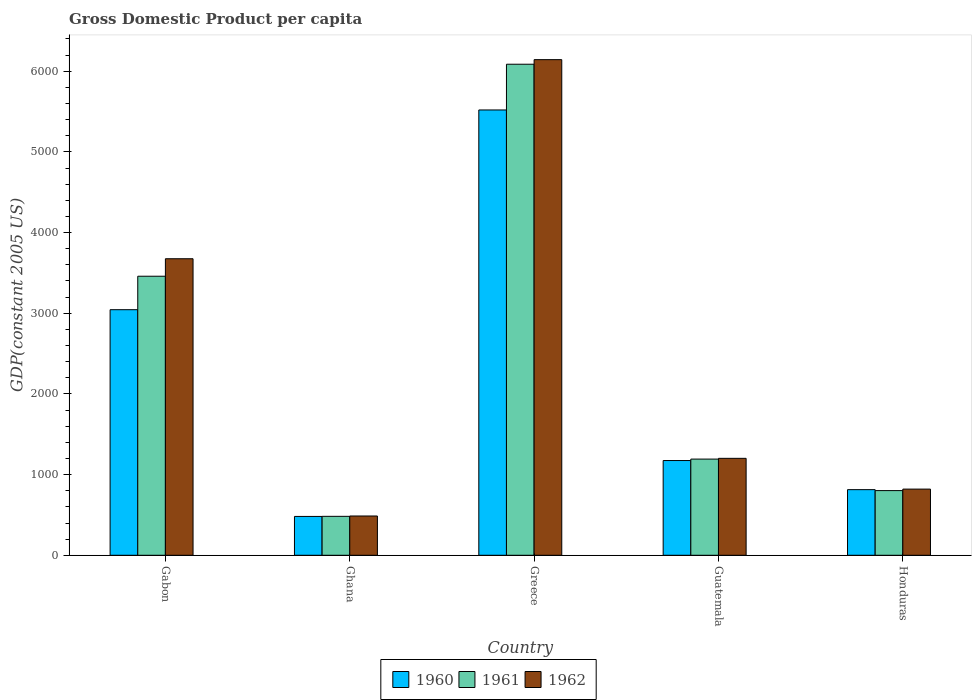How many groups of bars are there?
Give a very brief answer. 5. Are the number of bars per tick equal to the number of legend labels?
Your answer should be very brief. Yes. What is the GDP per capita in 1961 in Ghana?
Your response must be concise. 482.59. Across all countries, what is the maximum GDP per capita in 1961?
Offer a very short reply. 6087.1. Across all countries, what is the minimum GDP per capita in 1961?
Your response must be concise. 482.59. In which country was the GDP per capita in 1962 maximum?
Make the answer very short. Greece. In which country was the GDP per capita in 1960 minimum?
Your answer should be compact. Ghana. What is the total GDP per capita in 1961 in the graph?
Provide a short and direct response. 1.20e+04. What is the difference between the GDP per capita in 1960 in Greece and that in Guatemala?
Provide a succinct answer. 4345.65. What is the difference between the GDP per capita in 1960 in Greece and the GDP per capita in 1962 in Ghana?
Offer a terse response. 5033.19. What is the average GDP per capita in 1960 per country?
Offer a very short reply. 2206.74. What is the difference between the GDP per capita of/in 1960 and GDP per capita of/in 1962 in Gabon?
Provide a succinct answer. -631.6. In how many countries, is the GDP per capita in 1960 greater than 1600 US$?
Offer a terse response. 2. What is the ratio of the GDP per capita in 1962 in Ghana to that in Greece?
Offer a terse response. 0.08. What is the difference between the highest and the second highest GDP per capita in 1961?
Provide a succinct answer. -2266.73. What is the difference between the highest and the lowest GDP per capita in 1961?
Ensure brevity in your answer.  5604.5. What does the 2nd bar from the left in Honduras represents?
Offer a very short reply. 1961. How many bars are there?
Give a very brief answer. 15. Are all the bars in the graph horizontal?
Keep it short and to the point. No. How many countries are there in the graph?
Your answer should be very brief. 5. What is the difference between two consecutive major ticks on the Y-axis?
Ensure brevity in your answer.  1000. Does the graph contain grids?
Your response must be concise. No. How many legend labels are there?
Make the answer very short. 3. What is the title of the graph?
Make the answer very short. Gross Domestic Product per capita. What is the label or title of the X-axis?
Keep it short and to the point. Country. What is the label or title of the Y-axis?
Offer a very short reply. GDP(constant 2005 US). What is the GDP(constant 2005 US) of 1960 in Gabon?
Offer a very short reply. 3044.16. What is the GDP(constant 2005 US) in 1961 in Gabon?
Your response must be concise. 3459.15. What is the GDP(constant 2005 US) in 1962 in Gabon?
Your response must be concise. 3675.76. What is the GDP(constant 2005 US) of 1960 in Ghana?
Provide a succinct answer. 481.62. What is the GDP(constant 2005 US) of 1961 in Ghana?
Offer a terse response. 482.59. What is the GDP(constant 2005 US) of 1962 in Ghana?
Offer a very short reply. 486.9. What is the GDP(constant 2005 US) of 1960 in Greece?
Provide a succinct answer. 5520.09. What is the GDP(constant 2005 US) in 1961 in Greece?
Ensure brevity in your answer.  6087.1. What is the GDP(constant 2005 US) in 1962 in Greece?
Your answer should be very brief. 6143.73. What is the GDP(constant 2005 US) of 1960 in Guatemala?
Offer a terse response. 1174.44. What is the GDP(constant 2005 US) of 1961 in Guatemala?
Your answer should be very brief. 1192.42. What is the GDP(constant 2005 US) in 1962 in Guatemala?
Provide a succinct answer. 1201.57. What is the GDP(constant 2005 US) of 1960 in Honduras?
Provide a succinct answer. 813.41. What is the GDP(constant 2005 US) of 1961 in Honduras?
Ensure brevity in your answer.  801.77. What is the GDP(constant 2005 US) in 1962 in Honduras?
Make the answer very short. 820.2. Across all countries, what is the maximum GDP(constant 2005 US) of 1960?
Offer a very short reply. 5520.09. Across all countries, what is the maximum GDP(constant 2005 US) in 1961?
Provide a succinct answer. 6087.1. Across all countries, what is the maximum GDP(constant 2005 US) of 1962?
Your answer should be compact. 6143.73. Across all countries, what is the minimum GDP(constant 2005 US) of 1960?
Your answer should be very brief. 481.62. Across all countries, what is the minimum GDP(constant 2005 US) of 1961?
Provide a succinct answer. 482.59. Across all countries, what is the minimum GDP(constant 2005 US) of 1962?
Provide a succinct answer. 486.9. What is the total GDP(constant 2005 US) in 1960 in the graph?
Your answer should be compact. 1.10e+04. What is the total GDP(constant 2005 US) of 1961 in the graph?
Provide a short and direct response. 1.20e+04. What is the total GDP(constant 2005 US) of 1962 in the graph?
Your answer should be compact. 1.23e+04. What is the difference between the GDP(constant 2005 US) in 1960 in Gabon and that in Ghana?
Your answer should be very brief. 2562.54. What is the difference between the GDP(constant 2005 US) in 1961 in Gabon and that in Ghana?
Ensure brevity in your answer.  2976.55. What is the difference between the GDP(constant 2005 US) in 1962 in Gabon and that in Ghana?
Provide a succinct answer. 3188.86. What is the difference between the GDP(constant 2005 US) in 1960 in Gabon and that in Greece?
Provide a succinct answer. -2475.93. What is the difference between the GDP(constant 2005 US) of 1961 in Gabon and that in Greece?
Offer a very short reply. -2627.95. What is the difference between the GDP(constant 2005 US) in 1962 in Gabon and that in Greece?
Keep it short and to the point. -2467.97. What is the difference between the GDP(constant 2005 US) of 1960 in Gabon and that in Guatemala?
Provide a short and direct response. 1869.72. What is the difference between the GDP(constant 2005 US) in 1961 in Gabon and that in Guatemala?
Make the answer very short. 2266.73. What is the difference between the GDP(constant 2005 US) in 1962 in Gabon and that in Guatemala?
Keep it short and to the point. 2474.19. What is the difference between the GDP(constant 2005 US) of 1960 in Gabon and that in Honduras?
Make the answer very short. 2230.75. What is the difference between the GDP(constant 2005 US) of 1961 in Gabon and that in Honduras?
Provide a short and direct response. 2657.37. What is the difference between the GDP(constant 2005 US) of 1962 in Gabon and that in Honduras?
Offer a terse response. 2855.56. What is the difference between the GDP(constant 2005 US) of 1960 in Ghana and that in Greece?
Provide a short and direct response. -5038.47. What is the difference between the GDP(constant 2005 US) of 1961 in Ghana and that in Greece?
Ensure brevity in your answer.  -5604.5. What is the difference between the GDP(constant 2005 US) of 1962 in Ghana and that in Greece?
Your answer should be very brief. -5656.83. What is the difference between the GDP(constant 2005 US) in 1960 in Ghana and that in Guatemala?
Make the answer very short. -692.82. What is the difference between the GDP(constant 2005 US) in 1961 in Ghana and that in Guatemala?
Offer a terse response. -709.82. What is the difference between the GDP(constant 2005 US) of 1962 in Ghana and that in Guatemala?
Your response must be concise. -714.67. What is the difference between the GDP(constant 2005 US) in 1960 in Ghana and that in Honduras?
Give a very brief answer. -331.79. What is the difference between the GDP(constant 2005 US) in 1961 in Ghana and that in Honduras?
Ensure brevity in your answer.  -319.18. What is the difference between the GDP(constant 2005 US) in 1962 in Ghana and that in Honduras?
Your answer should be compact. -333.3. What is the difference between the GDP(constant 2005 US) of 1960 in Greece and that in Guatemala?
Make the answer very short. 4345.65. What is the difference between the GDP(constant 2005 US) of 1961 in Greece and that in Guatemala?
Make the answer very short. 4894.68. What is the difference between the GDP(constant 2005 US) of 1962 in Greece and that in Guatemala?
Offer a terse response. 4942.16. What is the difference between the GDP(constant 2005 US) in 1960 in Greece and that in Honduras?
Keep it short and to the point. 4706.68. What is the difference between the GDP(constant 2005 US) in 1961 in Greece and that in Honduras?
Your answer should be compact. 5285.32. What is the difference between the GDP(constant 2005 US) of 1962 in Greece and that in Honduras?
Give a very brief answer. 5323.53. What is the difference between the GDP(constant 2005 US) in 1960 in Guatemala and that in Honduras?
Offer a very short reply. 361.03. What is the difference between the GDP(constant 2005 US) of 1961 in Guatemala and that in Honduras?
Provide a succinct answer. 390.64. What is the difference between the GDP(constant 2005 US) of 1962 in Guatemala and that in Honduras?
Make the answer very short. 381.38. What is the difference between the GDP(constant 2005 US) of 1960 in Gabon and the GDP(constant 2005 US) of 1961 in Ghana?
Ensure brevity in your answer.  2561.57. What is the difference between the GDP(constant 2005 US) in 1960 in Gabon and the GDP(constant 2005 US) in 1962 in Ghana?
Provide a succinct answer. 2557.26. What is the difference between the GDP(constant 2005 US) in 1961 in Gabon and the GDP(constant 2005 US) in 1962 in Ghana?
Offer a very short reply. 2972.24. What is the difference between the GDP(constant 2005 US) in 1960 in Gabon and the GDP(constant 2005 US) in 1961 in Greece?
Your answer should be very brief. -3042.93. What is the difference between the GDP(constant 2005 US) of 1960 in Gabon and the GDP(constant 2005 US) of 1962 in Greece?
Provide a succinct answer. -3099.57. What is the difference between the GDP(constant 2005 US) of 1961 in Gabon and the GDP(constant 2005 US) of 1962 in Greece?
Provide a succinct answer. -2684.59. What is the difference between the GDP(constant 2005 US) in 1960 in Gabon and the GDP(constant 2005 US) in 1961 in Guatemala?
Make the answer very short. 1851.75. What is the difference between the GDP(constant 2005 US) in 1960 in Gabon and the GDP(constant 2005 US) in 1962 in Guatemala?
Offer a terse response. 1842.59. What is the difference between the GDP(constant 2005 US) in 1961 in Gabon and the GDP(constant 2005 US) in 1962 in Guatemala?
Offer a very short reply. 2257.57. What is the difference between the GDP(constant 2005 US) of 1960 in Gabon and the GDP(constant 2005 US) of 1961 in Honduras?
Offer a very short reply. 2242.39. What is the difference between the GDP(constant 2005 US) of 1960 in Gabon and the GDP(constant 2005 US) of 1962 in Honduras?
Offer a terse response. 2223.96. What is the difference between the GDP(constant 2005 US) of 1961 in Gabon and the GDP(constant 2005 US) of 1962 in Honduras?
Provide a short and direct response. 2638.95. What is the difference between the GDP(constant 2005 US) in 1960 in Ghana and the GDP(constant 2005 US) in 1961 in Greece?
Keep it short and to the point. -5605.48. What is the difference between the GDP(constant 2005 US) of 1960 in Ghana and the GDP(constant 2005 US) of 1962 in Greece?
Provide a short and direct response. -5662.11. What is the difference between the GDP(constant 2005 US) in 1961 in Ghana and the GDP(constant 2005 US) in 1962 in Greece?
Make the answer very short. -5661.14. What is the difference between the GDP(constant 2005 US) in 1960 in Ghana and the GDP(constant 2005 US) in 1961 in Guatemala?
Ensure brevity in your answer.  -710.8. What is the difference between the GDP(constant 2005 US) of 1960 in Ghana and the GDP(constant 2005 US) of 1962 in Guatemala?
Your response must be concise. -719.96. What is the difference between the GDP(constant 2005 US) of 1961 in Ghana and the GDP(constant 2005 US) of 1962 in Guatemala?
Ensure brevity in your answer.  -718.98. What is the difference between the GDP(constant 2005 US) of 1960 in Ghana and the GDP(constant 2005 US) of 1961 in Honduras?
Your answer should be compact. -320.16. What is the difference between the GDP(constant 2005 US) of 1960 in Ghana and the GDP(constant 2005 US) of 1962 in Honduras?
Your answer should be very brief. -338.58. What is the difference between the GDP(constant 2005 US) in 1961 in Ghana and the GDP(constant 2005 US) in 1962 in Honduras?
Give a very brief answer. -337.61. What is the difference between the GDP(constant 2005 US) in 1960 in Greece and the GDP(constant 2005 US) in 1961 in Guatemala?
Provide a succinct answer. 4327.67. What is the difference between the GDP(constant 2005 US) in 1960 in Greece and the GDP(constant 2005 US) in 1962 in Guatemala?
Provide a short and direct response. 4318.51. What is the difference between the GDP(constant 2005 US) of 1961 in Greece and the GDP(constant 2005 US) of 1962 in Guatemala?
Give a very brief answer. 4885.52. What is the difference between the GDP(constant 2005 US) in 1960 in Greece and the GDP(constant 2005 US) in 1961 in Honduras?
Make the answer very short. 4718.31. What is the difference between the GDP(constant 2005 US) in 1960 in Greece and the GDP(constant 2005 US) in 1962 in Honduras?
Your answer should be very brief. 4699.89. What is the difference between the GDP(constant 2005 US) of 1961 in Greece and the GDP(constant 2005 US) of 1962 in Honduras?
Give a very brief answer. 5266.9. What is the difference between the GDP(constant 2005 US) in 1960 in Guatemala and the GDP(constant 2005 US) in 1961 in Honduras?
Ensure brevity in your answer.  372.67. What is the difference between the GDP(constant 2005 US) in 1960 in Guatemala and the GDP(constant 2005 US) in 1962 in Honduras?
Your answer should be compact. 354.24. What is the difference between the GDP(constant 2005 US) of 1961 in Guatemala and the GDP(constant 2005 US) of 1962 in Honduras?
Keep it short and to the point. 372.22. What is the average GDP(constant 2005 US) of 1960 per country?
Keep it short and to the point. 2206.74. What is the average GDP(constant 2005 US) of 1961 per country?
Your response must be concise. 2404.61. What is the average GDP(constant 2005 US) of 1962 per country?
Provide a short and direct response. 2465.63. What is the difference between the GDP(constant 2005 US) of 1960 and GDP(constant 2005 US) of 1961 in Gabon?
Your response must be concise. -414.98. What is the difference between the GDP(constant 2005 US) of 1960 and GDP(constant 2005 US) of 1962 in Gabon?
Ensure brevity in your answer.  -631.6. What is the difference between the GDP(constant 2005 US) in 1961 and GDP(constant 2005 US) in 1962 in Gabon?
Your answer should be very brief. -216.62. What is the difference between the GDP(constant 2005 US) in 1960 and GDP(constant 2005 US) in 1961 in Ghana?
Give a very brief answer. -0.97. What is the difference between the GDP(constant 2005 US) in 1960 and GDP(constant 2005 US) in 1962 in Ghana?
Your answer should be compact. -5.28. What is the difference between the GDP(constant 2005 US) of 1961 and GDP(constant 2005 US) of 1962 in Ghana?
Your answer should be very brief. -4.31. What is the difference between the GDP(constant 2005 US) of 1960 and GDP(constant 2005 US) of 1961 in Greece?
Give a very brief answer. -567.01. What is the difference between the GDP(constant 2005 US) of 1960 and GDP(constant 2005 US) of 1962 in Greece?
Your answer should be very brief. -623.64. What is the difference between the GDP(constant 2005 US) of 1961 and GDP(constant 2005 US) of 1962 in Greece?
Provide a short and direct response. -56.63. What is the difference between the GDP(constant 2005 US) in 1960 and GDP(constant 2005 US) in 1961 in Guatemala?
Your response must be concise. -17.97. What is the difference between the GDP(constant 2005 US) in 1960 and GDP(constant 2005 US) in 1962 in Guatemala?
Provide a succinct answer. -27.13. What is the difference between the GDP(constant 2005 US) in 1961 and GDP(constant 2005 US) in 1962 in Guatemala?
Make the answer very short. -9.16. What is the difference between the GDP(constant 2005 US) of 1960 and GDP(constant 2005 US) of 1961 in Honduras?
Offer a very short reply. 11.63. What is the difference between the GDP(constant 2005 US) of 1960 and GDP(constant 2005 US) of 1962 in Honduras?
Provide a succinct answer. -6.79. What is the difference between the GDP(constant 2005 US) in 1961 and GDP(constant 2005 US) in 1962 in Honduras?
Make the answer very short. -18.42. What is the ratio of the GDP(constant 2005 US) in 1960 in Gabon to that in Ghana?
Your response must be concise. 6.32. What is the ratio of the GDP(constant 2005 US) of 1961 in Gabon to that in Ghana?
Your answer should be very brief. 7.17. What is the ratio of the GDP(constant 2005 US) of 1962 in Gabon to that in Ghana?
Offer a terse response. 7.55. What is the ratio of the GDP(constant 2005 US) of 1960 in Gabon to that in Greece?
Your response must be concise. 0.55. What is the ratio of the GDP(constant 2005 US) in 1961 in Gabon to that in Greece?
Provide a short and direct response. 0.57. What is the ratio of the GDP(constant 2005 US) in 1962 in Gabon to that in Greece?
Make the answer very short. 0.6. What is the ratio of the GDP(constant 2005 US) in 1960 in Gabon to that in Guatemala?
Your response must be concise. 2.59. What is the ratio of the GDP(constant 2005 US) of 1961 in Gabon to that in Guatemala?
Offer a very short reply. 2.9. What is the ratio of the GDP(constant 2005 US) of 1962 in Gabon to that in Guatemala?
Make the answer very short. 3.06. What is the ratio of the GDP(constant 2005 US) in 1960 in Gabon to that in Honduras?
Make the answer very short. 3.74. What is the ratio of the GDP(constant 2005 US) in 1961 in Gabon to that in Honduras?
Provide a succinct answer. 4.31. What is the ratio of the GDP(constant 2005 US) in 1962 in Gabon to that in Honduras?
Make the answer very short. 4.48. What is the ratio of the GDP(constant 2005 US) of 1960 in Ghana to that in Greece?
Your answer should be very brief. 0.09. What is the ratio of the GDP(constant 2005 US) of 1961 in Ghana to that in Greece?
Provide a short and direct response. 0.08. What is the ratio of the GDP(constant 2005 US) of 1962 in Ghana to that in Greece?
Offer a terse response. 0.08. What is the ratio of the GDP(constant 2005 US) in 1960 in Ghana to that in Guatemala?
Provide a short and direct response. 0.41. What is the ratio of the GDP(constant 2005 US) in 1961 in Ghana to that in Guatemala?
Ensure brevity in your answer.  0.4. What is the ratio of the GDP(constant 2005 US) in 1962 in Ghana to that in Guatemala?
Make the answer very short. 0.41. What is the ratio of the GDP(constant 2005 US) in 1960 in Ghana to that in Honduras?
Provide a short and direct response. 0.59. What is the ratio of the GDP(constant 2005 US) of 1961 in Ghana to that in Honduras?
Your response must be concise. 0.6. What is the ratio of the GDP(constant 2005 US) of 1962 in Ghana to that in Honduras?
Your answer should be compact. 0.59. What is the ratio of the GDP(constant 2005 US) of 1960 in Greece to that in Guatemala?
Offer a very short reply. 4.7. What is the ratio of the GDP(constant 2005 US) in 1961 in Greece to that in Guatemala?
Your answer should be compact. 5.1. What is the ratio of the GDP(constant 2005 US) of 1962 in Greece to that in Guatemala?
Your response must be concise. 5.11. What is the ratio of the GDP(constant 2005 US) of 1960 in Greece to that in Honduras?
Provide a succinct answer. 6.79. What is the ratio of the GDP(constant 2005 US) in 1961 in Greece to that in Honduras?
Keep it short and to the point. 7.59. What is the ratio of the GDP(constant 2005 US) of 1962 in Greece to that in Honduras?
Make the answer very short. 7.49. What is the ratio of the GDP(constant 2005 US) of 1960 in Guatemala to that in Honduras?
Your response must be concise. 1.44. What is the ratio of the GDP(constant 2005 US) in 1961 in Guatemala to that in Honduras?
Give a very brief answer. 1.49. What is the ratio of the GDP(constant 2005 US) of 1962 in Guatemala to that in Honduras?
Make the answer very short. 1.47. What is the difference between the highest and the second highest GDP(constant 2005 US) of 1960?
Give a very brief answer. 2475.93. What is the difference between the highest and the second highest GDP(constant 2005 US) of 1961?
Give a very brief answer. 2627.95. What is the difference between the highest and the second highest GDP(constant 2005 US) of 1962?
Make the answer very short. 2467.97. What is the difference between the highest and the lowest GDP(constant 2005 US) in 1960?
Provide a short and direct response. 5038.47. What is the difference between the highest and the lowest GDP(constant 2005 US) in 1961?
Offer a very short reply. 5604.5. What is the difference between the highest and the lowest GDP(constant 2005 US) of 1962?
Your answer should be compact. 5656.83. 